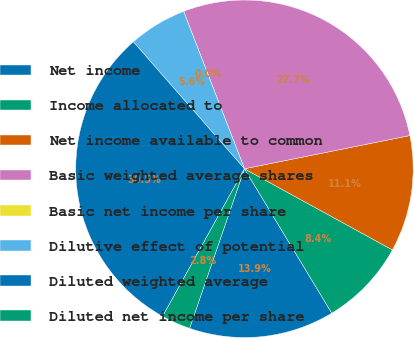Convert chart to OTSL. <chart><loc_0><loc_0><loc_500><loc_500><pie_chart><fcel>Net income<fcel>Income allocated to<fcel>Net income available to common<fcel>Basic weighted average shares<fcel>Basic net income per share<fcel>Dilutive effect of potential<fcel>Diluted weighted average<fcel>Diluted net income per share<nl><fcel>13.93%<fcel>8.36%<fcel>11.14%<fcel>27.72%<fcel>0.0%<fcel>5.57%<fcel>30.5%<fcel>2.79%<nl></chart> 